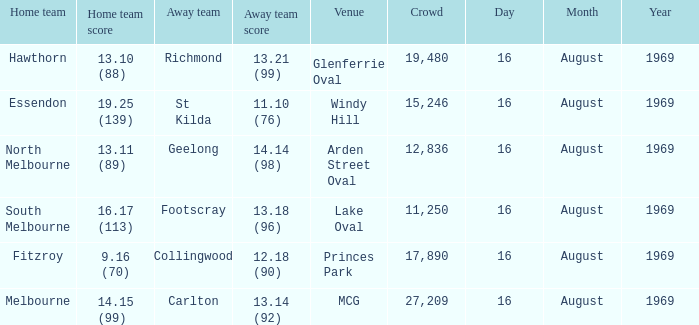When was the game played at Lake Oval? 16 August 1969. 